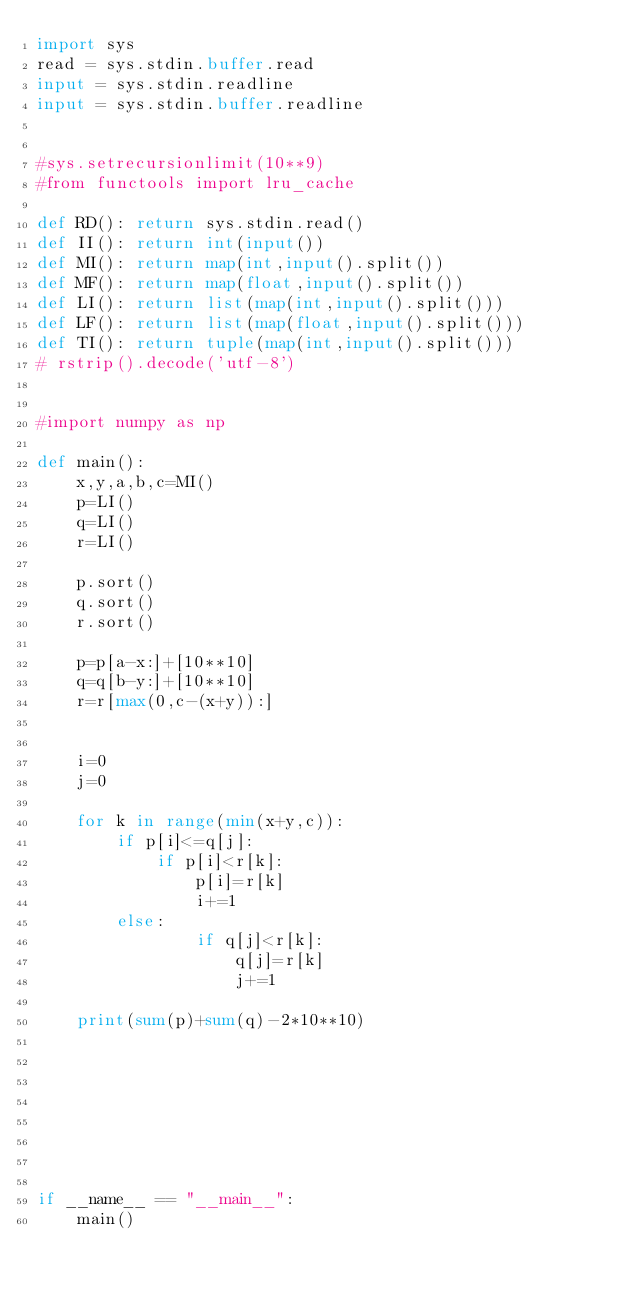Convert code to text. <code><loc_0><loc_0><loc_500><loc_500><_Python_>import sys
read = sys.stdin.buffer.read
input = sys.stdin.readline
input = sys.stdin.buffer.readline


#sys.setrecursionlimit(10**9)
#from functools import lru_cache

def RD(): return sys.stdin.read()
def II(): return int(input())
def MI(): return map(int,input().split())
def MF(): return map(float,input().split())
def LI(): return list(map(int,input().split()))
def LF(): return list(map(float,input().split()))
def TI(): return tuple(map(int,input().split()))
# rstrip().decode('utf-8')


#import numpy as np

def main():
	x,y,a,b,c=MI()
	p=LI()
	q=LI()
	r=LI()

	p.sort()
	q.sort()
	r.sort()

	p=p[a-x:]+[10**10]
	q=q[b-y:]+[10**10]
	r=r[max(0,c-(x+y)):]


	i=0
	j=0

	for k in range(min(x+y,c)):
		if p[i]<=q[j]:
			if p[i]<r[k]:
				p[i]=r[k]
				i+=1
		else:
				if q[j]<r[k]:
					q[j]=r[k]
					j+=1

	print(sum(p)+sum(q)-2*10**10)








if __name__ == "__main__":
	main()</code> 